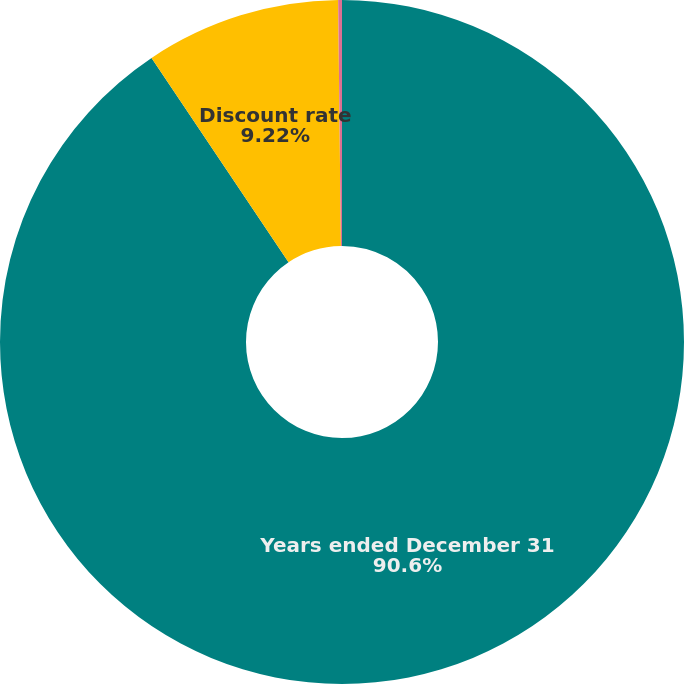Convert chart to OTSL. <chart><loc_0><loc_0><loc_500><loc_500><pie_chart><fcel>Years ended December 31<fcel>Discount rate<fcel>Rate of compensation increase<nl><fcel>90.6%<fcel>9.22%<fcel>0.18%<nl></chart> 